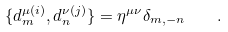<formula> <loc_0><loc_0><loc_500><loc_500>\{ d ^ { \mu ( i ) } _ { m } , d ^ { \nu ( j ) } _ { n } \} = \eta ^ { \mu \nu } \delta _ { m , - n } \quad .</formula> 